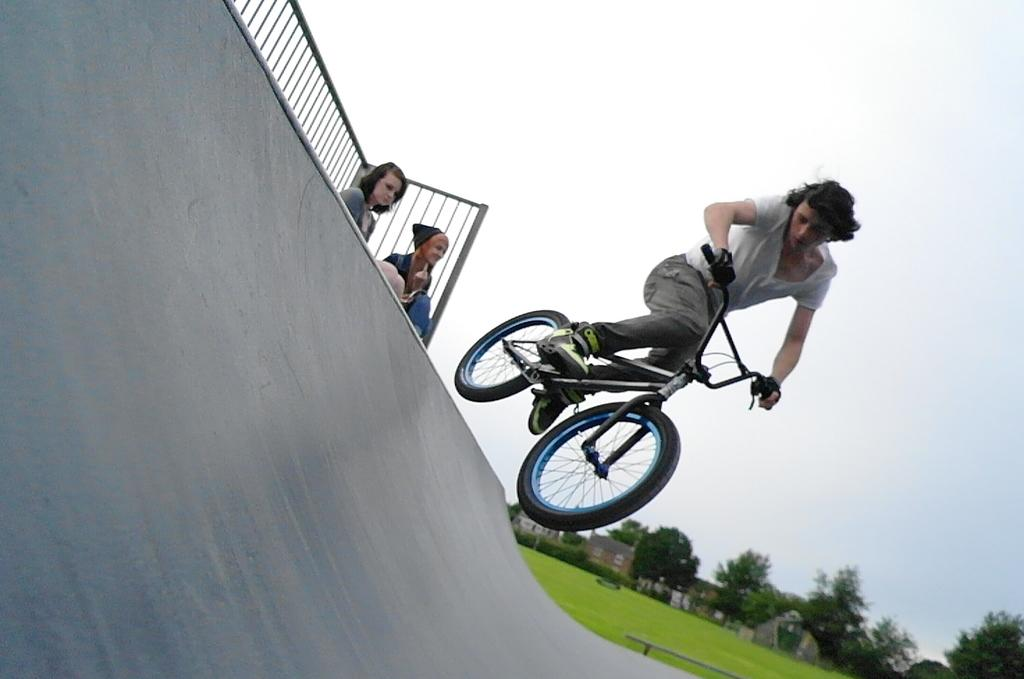What is the person in the image doing? The person in the image is cycling. How many women are in the image? There are two women in the image. What can be seen near the women in the image? There is railing visible in the image. What type of surface is present in the image? There is a surface (possibly a path or road) in the image. What type of vegetation is present in the image? There is grass in the image. What type of structures are visible in the image? There are houses in the image. What type of natural elements are visible in the image? There are trees in the image. What is visible in the background of the image? The sky is visible in the background of the image. What does the stranger desire in the image? There is no stranger present in the image, so it is not possible to determine their desires. 